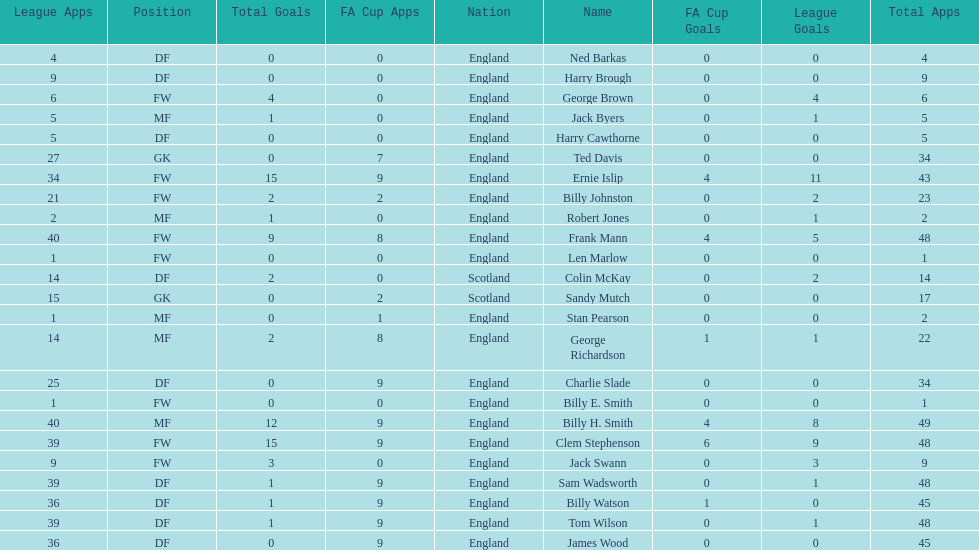What is the average number of scotland's total apps? 15.5. 